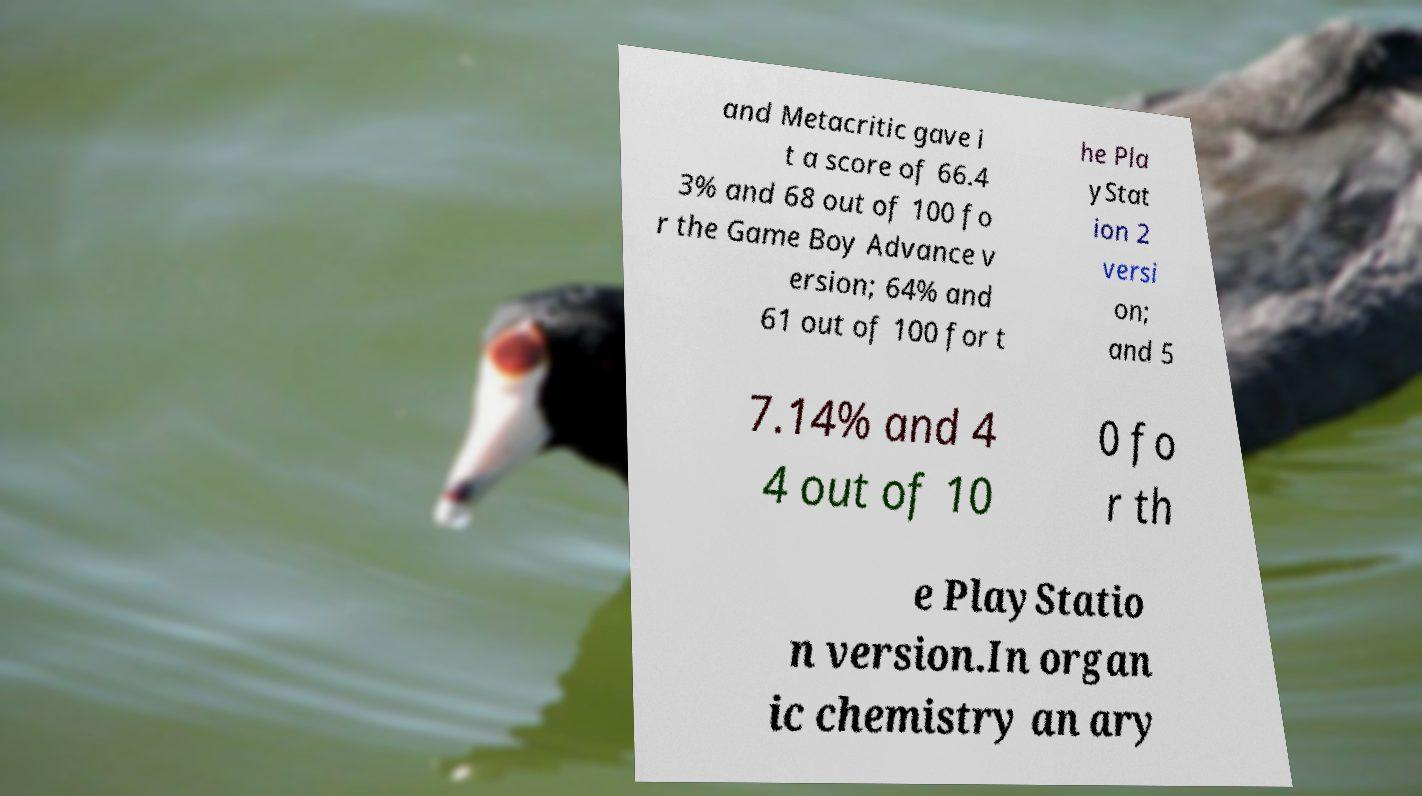Please read and relay the text visible in this image. What does it say? and Metacritic gave i t a score of 66.4 3% and 68 out of 100 fo r the Game Boy Advance v ersion; 64% and 61 out of 100 for t he Pla yStat ion 2 versi on; and 5 7.14% and 4 4 out of 10 0 fo r th e PlayStatio n version.In organ ic chemistry an ary 